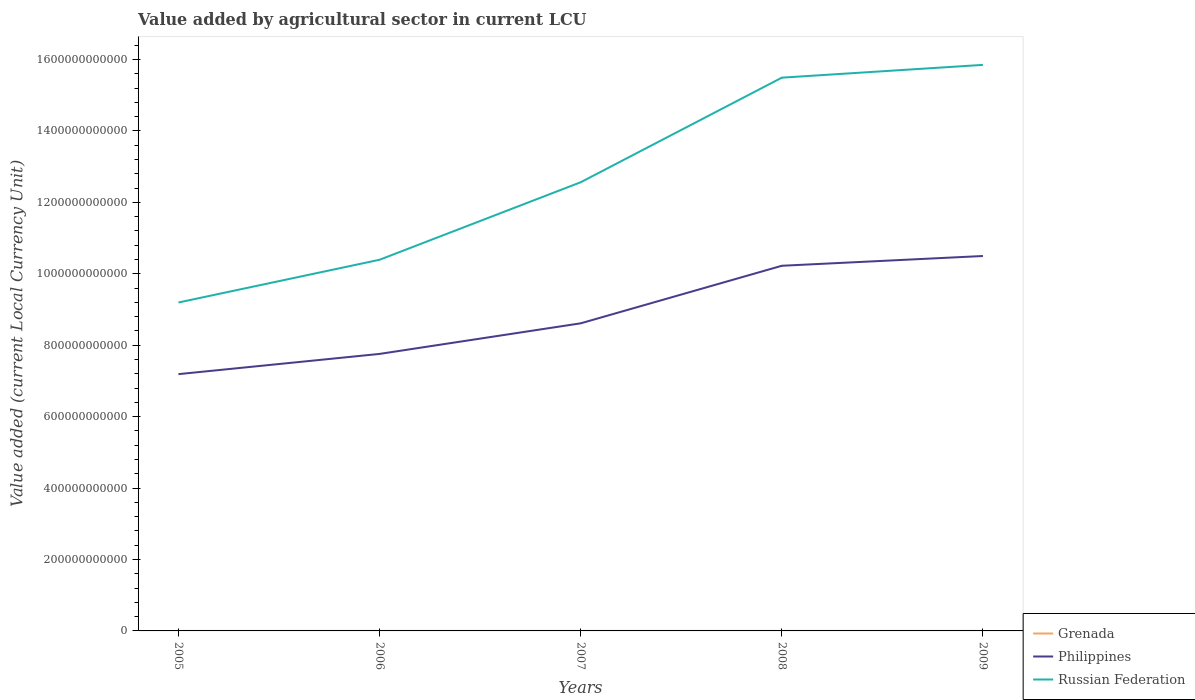Does the line corresponding to Grenada intersect with the line corresponding to Russian Federation?
Provide a succinct answer. No. Is the number of lines equal to the number of legend labels?
Give a very brief answer. Yes. Across all years, what is the maximum value added by agricultural sector in Russian Federation?
Provide a succinct answer. 9.20e+11. What is the total value added by agricultural sector in Philippines in the graph?
Ensure brevity in your answer.  -3.31e+11. What is the difference between the highest and the second highest value added by agricultural sector in Grenada?
Offer a very short reply. 4.07e+07. What is the difference between the highest and the lowest value added by agricultural sector in Philippines?
Ensure brevity in your answer.  2. Is the value added by agricultural sector in Philippines strictly greater than the value added by agricultural sector in Grenada over the years?
Your answer should be compact. No. How many lines are there?
Your answer should be compact. 3. How many years are there in the graph?
Ensure brevity in your answer.  5. What is the difference between two consecutive major ticks on the Y-axis?
Your answer should be very brief. 2.00e+11. Are the values on the major ticks of Y-axis written in scientific E-notation?
Give a very brief answer. No. Does the graph contain any zero values?
Offer a very short reply. No. Does the graph contain grids?
Offer a terse response. No. How many legend labels are there?
Make the answer very short. 3. How are the legend labels stacked?
Provide a short and direct response. Vertical. What is the title of the graph?
Offer a terse response. Value added by agricultural sector in current LCU. What is the label or title of the Y-axis?
Your answer should be very brief. Value added (current Local Currency Unit). What is the Value added (current Local Currency Unit) of Grenada in 2005?
Offer a very short reply. 5.57e+07. What is the Value added (current Local Currency Unit) of Philippines in 2005?
Offer a terse response. 7.19e+11. What is the Value added (current Local Currency Unit) of Russian Federation in 2005?
Your answer should be compact. 9.20e+11. What is the Value added (current Local Currency Unit) in Grenada in 2006?
Offer a very short reply. 7.34e+07. What is the Value added (current Local Currency Unit) of Philippines in 2006?
Offer a very short reply. 7.76e+11. What is the Value added (current Local Currency Unit) of Russian Federation in 2006?
Offer a terse response. 1.04e+12. What is the Value added (current Local Currency Unit) of Grenada in 2007?
Offer a terse response. 7.29e+07. What is the Value added (current Local Currency Unit) in Philippines in 2007?
Offer a terse response. 8.61e+11. What is the Value added (current Local Currency Unit) of Russian Federation in 2007?
Provide a succinct answer. 1.26e+12. What is the Value added (current Local Currency Unit) of Grenada in 2008?
Offer a very short reply. 8.40e+07. What is the Value added (current Local Currency Unit) in Philippines in 2008?
Offer a very short reply. 1.02e+12. What is the Value added (current Local Currency Unit) in Russian Federation in 2008?
Keep it short and to the point. 1.55e+12. What is the Value added (current Local Currency Unit) of Grenada in 2009?
Your answer should be compact. 9.63e+07. What is the Value added (current Local Currency Unit) of Philippines in 2009?
Make the answer very short. 1.05e+12. What is the Value added (current Local Currency Unit) in Russian Federation in 2009?
Give a very brief answer. 1.59e+12. Across all years, what is the maximum Value added (current Local Currency Unit) in Grenada?
Give a very brief answer. 9.63e+07. Across all years, what is the maximum Value added (current Local Currency Unit) of Philippines?
Offer a very short reply. 1.05e+12. Across all years, what is the maximum Value added (current Local Currency Unit) in Russian Federation?
Offer a terse response. 1.59e+12. Across all years, what is the minimum Value added (current Local Currency Unit) of Grenada?
Your response must be concise. 5.57e+07. Across all years, what is the minimum Value added (current Local Currency Unit) in Philippines?
Ensure brevity in your answer.  7.19e+11. Across all years, what is the minimum Value added (current Local Currency Unit) of Russian Federation?
Give a very brief answer. 9.20e+11. What is the total Value added (current Local Currency Unit) of Grenada in the graph?
Provide a succinct answer. 3.82e+08. What is the total Value added (current Local Currency Unit) in Philippines in the graph?
Make the answer very short. 4.43e+12. What is the total Value added (current Local Currency Unit) in Russian Federation in the graph?
Make the answer very short. 6.35e+12. What is the difference between the Value added (current Local Currency Unit) in Grenada in 2005 and that in 2006?
Offer a very short reply. -1.77e+07. What is the difference between the Value added (current Local Currency Unit) in Philippines in 2005 and that in 2006?
Make the answer very short. -5.66e+1. What is the difference between the Value added (current Local Currency Unit) of Russian Federation in 2005 and that in 2006?
Offer a very short reply. -1.20e+11. What is the difference between the Value added (current Local Currency Unit) in Grenada in 2005 and that in 2007?
Provide a short and direct response. -1.72e+07. What is the difference between the Value added (current Local Currency Unit) of Philippines in 2005 and that in 2007?
Your answer should be very brief. -1.42e+11. What is the difference between the Value added (current Local Currency Unit) of Russian Federation in 2005 and that in 2007?
Provide a short and direct response. -3.37e+11. What is the difference between the Value added (current Local Currency Unit) of Grenada in 2005 and that in 2008?
Offer a terse response. -2.84e+07. What is the difference between the Value added (current Local Currency Unit) of Philippines in 2005 and that in 2008?
Offer a very short reply. -3.03e+11. What is the difference between the Value added (current Local Currency Unit) in Russian Federation in 2005 and that in 2008?
Offer a very short reply. -6.30e+11. What is the difference between the Value added (current Local Currency Unit) in Grenada in 2005 and that in 2009?
Ensure brevity in your answer.  -4.07e+07. What is the difference between the Value added (current Local Currency Unit) of Philippines in 2005 and that in 2009?
Make the answer very short. -3.31e+11. What is the difference between the Value added (current Local Currency Unit) of Russian Federation in 2005 and that in 2009?
Offer a very short reply. -6.65e+11. What is the difference between the Value added (current Local Currency Unit) in Grenada in 2006 and that in 2007?
Offer a terse response. 5.30e+05. What is the difference between the Value added (current Local Currency Unit) in Philippines in 2006 and that in 2007?
Your response must be concise. -8.57e+1. What is the difference between the Value added (current Local Currency Unit) of Russian Federation in 2006 and that in 2007?
Your answer should be very brief. -2.17e+11. What is the difference between the Value added (current Local Currency Unit) of Grenada in 2006 and that in 2008?
Give a very brief answer. -1.06e+07. What is the difference between the Value added (current Local Currency Unit) in Philippines in 2006 and that in 2008?
Keep it short and to the point. -2.47e+11. What is the difference between the Value added (current Local Currency Unit) of Russian Federation in 2006 and that in 2008?
Give a very brief answer. -5.10e+11. What is the difference between the Value added (current Local Currency Unit) of Grenada in 2006 and that in 2009?
Offer a terse response. -2.29e+07. What is the difference between the Value added (current Local Currency Unit) in Philippines in 2006 and that in 2009?
Your answer should be compact. -2.74e+11. What is the difference between the Value added (current Local Currency Unit) of Russian Federation in 2006 and that in 2009?
Give a very brief answer. -5.46e+11. What is the difference between the Value added (current Local Currency Unit) of Grenada in 2007 and that in 2008?
Offer a very short reply. -1.12e+07. What is the difference between the Value added (current Local Currency Unit) in Philippines in 2007 and that in 2008?
Keep it short and to the point. -1.61e+11. What is the difference between the Value added (current Local Currency Unit) in Russian Federation in 2007 and that in 2008?
Offer a very short reply. -2.93e+11. What is the difference between the Value added (current Local Currency Unit) in Grenada in 2007 and that in 2009?
Give a very brief answer. -2.35e+07. What is the difference between the Value added (current Local Currency Unit) of Philippines in 2007 and that in 2009?
Ensure brevity in your answer.  -1.89e+11. What is the difference between the Value added (current Local Currency Unit) in Russian Federation in 2007 and that in 2009?
Give a very brief answer. -3.29e+11. What is the difference between the Value added (current Local Currency Unit) in Grenada in 2008 and that in 2009?
Offer a terse response. -1.23e+07. What is the difference between the Value added (current Local Currency Unit) of Philippines in 2008 and that in 2009?
Provide a short and direct response. -2.74e+1. What is the difference between the Value added (current Local Currency Unit) of Russian Federation in 2008 and that in 2009?
Give a very brief answer. -3.58e+1. What is the difference between the Value added (current Local Currency Unit) of Grenada in 2005 and the Value added (current Local Currency Unit) of Philippines in 2006?
Provide a short and direct response. -7.76e+11. What is the difference between the Value added (current Local Currency Unit) of Grenada in 2005 and the Value added (current Local Currency Unit) of Russian Federation in 2006?
Ensure brevity in your answer.  -1.04e+12. What is the difference between the Value added (current Local Currency Unit) of Philippines in 2005 and the Value added (current Local Currency Unit) of Russian Federation in 2006?
Ensure brevity in your answer.  -3.20e+11. What is the difference between the Value added (current Local Currency Unit) in Grenada in 2005 and the Value added (current Local Currency Unit) in Philippines in 2007?
Make the answer very short. -8.61e+11. What is the difference between the Value added (current Local Currency Unit) of Grenada in 2005 and the Value added (current Local Currency Unit) of Russian Federation in 2007?
Keep it short and to the point. -1.26e+12. What is the difference between the Value added (current Local Currency Unit) of Philippines in 2005 and the Value added (current Local Currency Unit) of Russian Federation in 2007?
Provide a short and direct response. -5.37e+11. What is the difference between the Value added (current Local Currency Unit) of Grenada in 2005 and the Value added (current Local Currency Unit) of Philippines in 2008?
Your answer should be very brief. -1.02e+12. What is the difference between the Value added (current Local Currency Unit) of Grenada in 2005 and the Value added (current Local Currency Unit) of Russian Federation in 2008?
Keep it short and to the point. -1.55e+12. What is the difference between the Value added (current Local Currency Unit) in Philippines in 2005 and the Value added (current Local Currency Unit) in Russian Federation in 2008?
Your response must be concise. -8.30e+11. What is the difference between the Value added (current Local Currency Unit) in Grenada in 2005 and the Value added (current Local Currency Unit) in Philippines in 2009?
Your response must be concise. -1.05e+12. What is the difference between the Value added (current Local Currency Unit) of Grenada in 2005 and the Value added (current Local Currency Unit) of Russian Federation in 2009?
Offer a very short reply. -1.59e+12. What is the difference between the Value added (current Local Currency Unit) of Philippines in 2005 and the Value added (current Local Currency Unit) of Russian Federation in 2009?
Your answer should be compact. -8.66e+11. What is the difference between the Value added (current Local Currency Unit) of Grenada in 2006 and the Value added (current Local Currency Unit) of Philippines in 2007?
Give a very brief answer. -8.61e+11. What is the difference between the Value added (current Local Currency Unit) in Grenada in 2006 and the Value added (current Local Currency Unit) in Russian Federation in 2007?
Offer a terse response. -1.26e+12. What is the difference between the Value added (current Local Currency Unit) in Philippines in 2006 and the Value added (current Local Currency Unit) in Russian Federation in 2007?
Keep it short and to the point. -4.81e+11. What is the difference between the Value added (current Local Currency Unit) of Grenada in 2006 and the Value added (current Local Currency Unit) of Philippines in 2008?
Provide a succinct answer. -1.02e+12. What is the difference between the Value added (current Local Currency Unit) of Grenada in 2006 and the Value added (current Local Currency Unit) of Russian Federation in 2008?
Provide a short and direct response. -1.55e+12. What is the difference between the Value added (current Local Currency Unit) in Philippines in 2006 and the Value added (current Local Currency Unit) in Russian Federation in 2008?
Ensure brevity in your answer.  -7.74e+11. What is the difference between the Value added (current Local Currency Unit) of Grenada in 2006 and the Value added (current Local Currency Unit) of Philippines in 2009?
Keep it short and to the point. -1.05e+12. What is the difference between the Value added (current Local Currency Unit) of Grenada in 2006 and the Value added (current Local Currency Unit) of Russian Federation in 2009?
Offer a terse response. -1.58e+12. What is the difference between the Value added (current Local Currency Unit) of Philippines in 2006 and the Value added (current Local Currency Unit) of Russian Federation in 2009?
Your answer should be compact. -8.09e+11. What is the difference between the Value added (current Local Currency Unit) of Grenada in 2007 and the Value added (current Local Currency Unit) of Philippines in 2008?
Your answer should be very brief. -1.02e+12. What is the difference between the Value added (current Local Currency Unit) of Grenada in 2007 and the Value added (current Local Currency Unit) of Russian Federation in 2008?
Ensure brevity in your answer.  -1.55e+12. What is the difference between the Value added (current Local Currency Unit) in Philippines in 2007 and the Value added (current Local Currency Unit) in Russian Federation in 2008?
Your response must be concise. -6.88e+11. What is the difference between the Value added (current Local Currency Unit) in Grenada in 2007 and the Value added (current Local Currency Unit) in Philippines in 2009?
Your answer should be very brief. -1.05e+12. What is the difference between the Value added (current Local Currency Unit) of Grenada in 2007 and the Value added (current Local Currency Unit) of Russian Federation in 2009?
Ensure brevity in your answer.  -1.58e+12. What is the difference between the Value added (current Local Currency Unit) of Philippines in 2007 and the Value added (current Local Currency Unit) of Russian Federation in 2009?
Make the answer very short. -7.24e+11. What is the difference between the Value added (current Local Currency Unit) in Grenada in 2008 and the Value added (current Local Currency Unit) in Philippines in 2009?
Your answer should be very brief. -1.05e+12. What is the difference between the Value added (current Local Currency Unit) of Grenada in 2008 and the Value added (current Local Currency Unit) of Russian Federation in 2009?
Your answer should be very brief. -1.58e+12. What is the difference between the Value added (current Local Currency Unit) in Philippines in 2008 and the Value added (current Local Currency Unit) in Russian Federation in 2009?
Offer a very short reply. -5.63e+11. What is the average Value added (current Local Currency Unit) of Grenada per year?
Your answer should be very brief. 7.65e+07. What is the average Value added (current Local Currency Unit) of Philippines per year?
Offer a very short reply. 8.86e+11. What is the average Value added (current Local Currency Unit) of Russian Federation per year?
Provide a short and direct response. 1.27e+12. In the year 2005, what is the difference between the Value added (current Local Currency Unit) in Grenada and Value added (current Local Currency Unit) in Philippines?
Provide a succinct answer. -7.19e+11. In the year 2005, what is the difference between the Value added (current Local Currency Unit) of Grenada and Value added (current Local Currency Unit) of Russian Federation?
Your response must be concise. -9.20e+11. In the year 2005, what is the difference between the Value added (current Local Currency Unit) in Philippines and Value added (current Local Currency Unit) in Russian Federation?
Ensure brevity in your answer.  -2.01e+11. In the year 2006, what is the difference between the Value added (current Local Currency Unit) of Grenada and Value added (current Local Currency Unit) of Philippines?
Ensure brevity in your answer.  -7.76e+11. In the year 2006, what is the difference between the Value added (current Local Currency Unit) of Grenada and Value added (current Local Currency Unit) of Russian Federation?
Ensure brevity in your answer.  -1.04e+12. In the year 2006, what is the difference between the Value added (current Local Currency Unit) in Philippines and Value added (current Local Currency Unit) in Russian Federation?
Your answer should be very brief. -2.64e+11. In the year 2007, what is the difference between the Value added (current Local Currency Unit) in Grenada and Value added (current Local Currency Unit) in Philippines?
Your answer should be compact. -8.61e+11. In the year 2007, what is the difference between the Value added (current Local Currency Unit) of Grenada and Value added (current Local Currency Unit) of Russian Federation?
Your answer should be very brief. -1.26e+12. In the year 2007, what is the difference between the Value added (current Local Currency Unit) of Philippines and Value added (current Local Currency Unit) of Russian Federation?
Your answer should be compact. -3.95e+11. In the year 2008, what is the difference between the Value added (current Local Currency Unit) in Grenada and Value added (current Local Currency Unit) in Philippines?
Your answer should be compact. -1.02e+12. In the year 2008, what is the difference between the Value added (current Local Currency Unit) in Grenada and Value added (current Local Currency Unit) in Russian Federation?
Offer a terse response. -1.55e+12. In the year 2008, what is the difference between the Value added (current Local Currency Unit) in Philippines and Value added (current Local Currency Unit) in Russian Federation?
Give a very brief answer. -5.27e+11. In the year 2009, what is the difference between the Value added (current Local Currency Unit) of Grenada and Value added (current Local Currency Unit) of Philippines?
Your response must be concise. -1.05e+12. In the year 2009, what is the difference between the Value added (current Local Currency Unit) in Grenada and Value added (current Local Currency Unit) in Russian Federation?
Your answer should be compact. -1.58e+12. In the year 2009, what is the difference between the Value added (current Local Currency Unit) in Philippines and Value added (current Local Currency Unit) in Russian Federation?
Offer a very short reply. -5.35e+11. What is the ratio of the Value added (current Local Currency Unit) of Grenada in 2005 to that in 2006?
Ensure brevity in your answer.  0.76. What is the ratio of the Value added (current Local Currency Unit) in Philippines in 2005 to that in 2006?
Your answer should be compact. 0.93. What is the ratio of the Value added (current Local Currency Unit) in Russian Federation in 2005 to that in 2006?
Make the answer very short. 0.88. What is the ratio of the Value added (current Local Currency Unit) in Grenada in 2005 to that in 2007?
Offer a terse response. 0.76. What is the ratio of the Value added (current Local Currency Unit) in Philippines in 2005 to that in 2007?
Offer a very short reply. 0.83. What is the ratio of the Value added (current Local Currency Unit) in Russian Federation in 2005 to that in 2007?
Provide a short and direct response. 0.73. What is the ratio of the Value added (current Local Currency Unit) of Grenada in 2005 to that in 2008?
Your answer should be compact. 0.66. What is the ratio of the Value added (current Local Currency Unit) of Philippines in 2005 to that in 2008?
Ensure brevity in your answer.  0.7. What is the ratio of the Value added (current Local Currency Unit) in Russian Federation in 2005 to that in 2008?
Your answer should be very brief. 0.59. What is the ratio of the Value added (current Local Currency Unit) in Grenada in 2005 to that in 2009?
Your answer should be compact. 0.58. What is the ratio of the Value added (current Local Currency Unit) in Philippines in 2005 to that in 2009?
Offer a very short reply. 0.68. What is the ratio of the Value added (current Local Currency Unit) of Russian Federation in 2005 to that in 2009?
Ensure brevity in your answer.  0.58. What is the ratio of the Value added (current Local Currency Unit) in Grenada in 2006 to that in 2007?
Make the answer very short. 1.01. What is the ratio of the Value added (current Local Currency Unit) of Philippines in 2006 to that in 2007?
Your answer should be very brief. 0.9. What is the ratio of the Value added (current Local Currency Unit) in Russian Federation in 2006 to that in 2007?
Offer a very short reply. 0.83. What is the ratio of the Value added (current Local Currency Unit) in Grenada in 2006 to that in 2008?
Offer a terse response. 0.87. What is the ratio of the Value added (current Local Currency Unit) in Philippines in 2006 to that in 2008?
Offer a terse response. 0.76. What is the ratio of the Value added (current Local Currency Unit) in Russian Federation in 2006 to that in 2008?
Offer a terse response. 0.67. What is the ratio of the Value added (current Local Currency Unit) in Grenada in 2006 to that in 2009?
Your answer should be very brief. 0.76. What is the ratio of the Value added (current Local Currency Unit) of Philippines in 2006 to that in 2009?
Offer a terse response. 0.74. What is the ratio of the Value added (current Local Currency Unit) of Russian Federation in 2006 to that in 2009?
Make the answer very short. 0.66. What is the ratio of the Value added (current Local Currency Unit) in Grenada in 2007 to that in 2008?
Your response must be concise. 0.87. What is the ratio of the Value added (current Local Currency Unit) of Philippines in 2007 to that in 2008?
Give a very brief answer. 0.84. What is the ratio of the Value added (current Local Currency Unit) of Russian Federation in 2007 to that in 2008?
Provide a succinct answer. 0.81. What is the ratio of the Value added (current Local Currency Unit) of Grenada in 2007 to that in 2009?
Provide a succinct answer. 0.76. What is the ratio of the Value added (current Local Currency Unit) of Philippines in 2007 to that in 2009?
Your answer should be very brief. 0.82. What is the ratio of the Value added (current Local Currency Unit) in Russian Federation in 2007 to that in 2009?
Your response must be concise. 0.79. What is the ratio of the Value added (current Local Currency Unit) in Grenada in 2008 to that in 2009?
Ensure brevity in your answer.  0.87. What is the ratio of the Value added (current Local Currency Unit) of Philippines in 2008 to that in 2009?
Offer a terse response. 0.97. What is the ratio of the Value added (current Local Currency Unit) in Russian Federation in 2008 to that in 2009?
Your answer should be very brief. 0.98. What is the difference between the highest and the second highest Value added (current Local Currency Unit) in Grenada?
Your answer should be compact. 1.23e+07. What is the difference between the highest and the second highest Value added (current Local Currency Unit) in Philippines?
Provide a succinct answer. 2.74e+1. What is the difference between the highest and the second highest Value added (current Local Currency Unit) of Russian Federation?
Your response must be concise. 3.58e+1. What is the difference between the highest and the lowest Value added (current Local Currency Unit) in Grenada?
Your answer should be very brief. 4.07e+07. What is the difference between the highest and the lowest Value added (current Local Currency Unit) of Philippines?
Make the answer very short. 3.31e+11. What is the difference between the highest and the lowest Value added (current Local Currency Unit) in Russian Federation?
Offer a very short reply. 6.65e+11. 